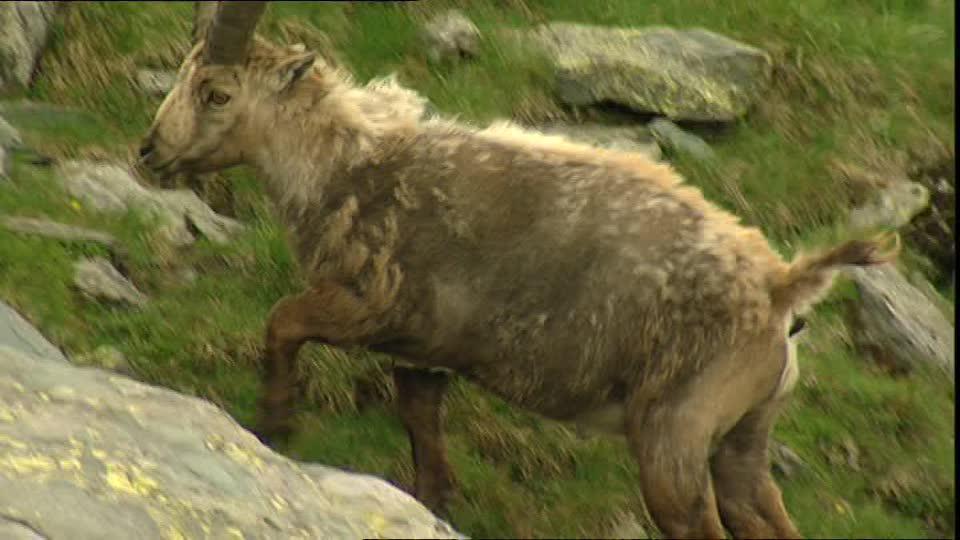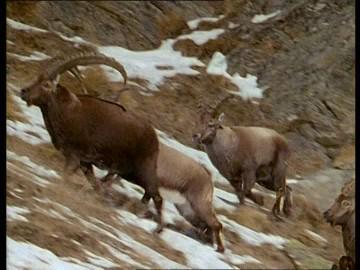The first image is the image on the left, the second image is the image on the right. Evaluate the accuracy of this statement regarding the images: "There is snow on the ground in the right image.". Is it true? Answer yes or no. Yes. 